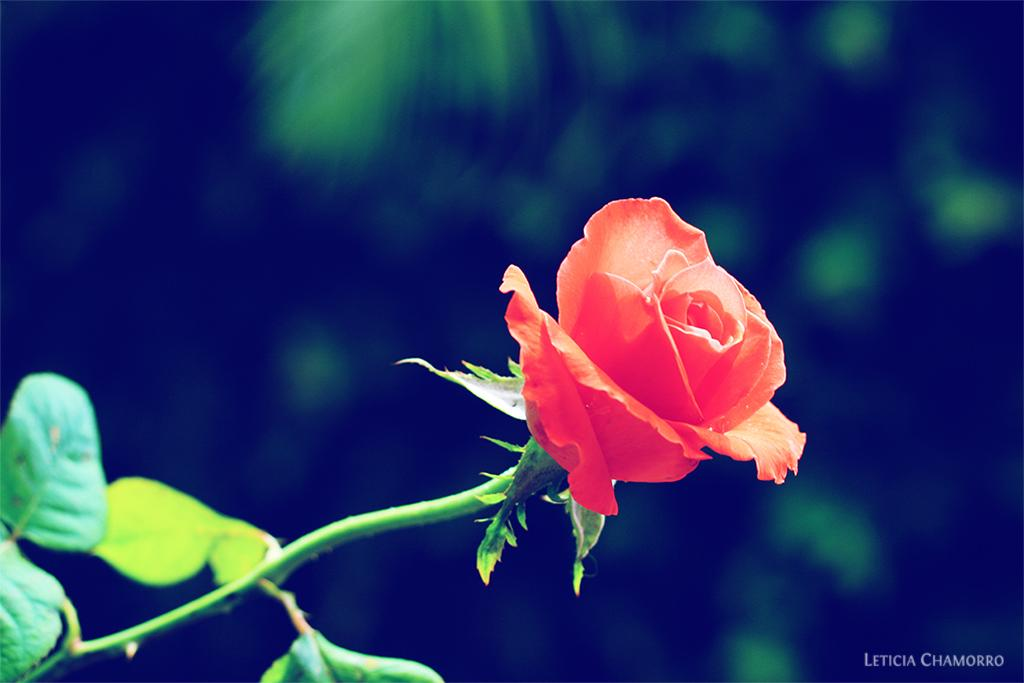What type of flower is in the image? There is a rose flower in the image. Can you describe the background of the image? The background of the image is blurry. What type of silk material is visible in the image? There is no silk material present in the image. What memory does the rose flower evoke in the image? The image does not convey any specific memories associated with the rose flower. 